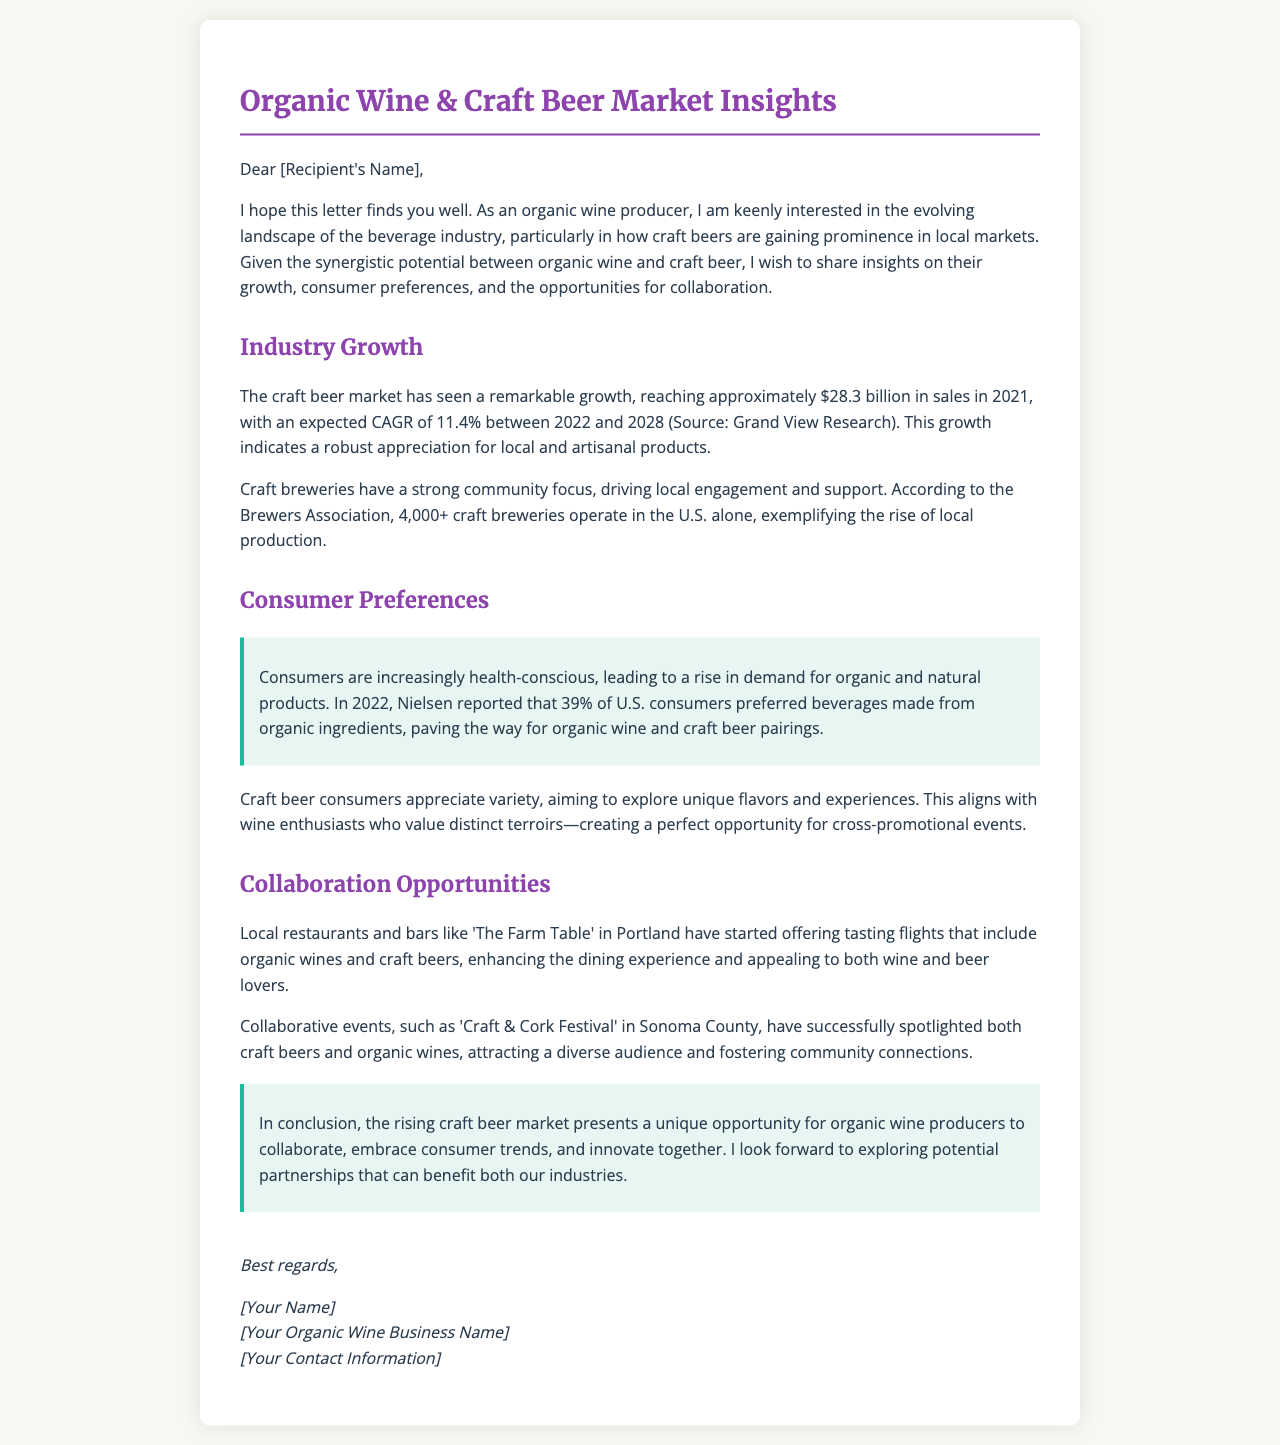what is the craft beer market's sales figure in 2021? The document states that the craft beer market reached approximately $28.3 billion in sales in 2021.
Answer: $28.3 billion what is the expected CAGR for the craft beer market from 2022 to 2028? The document mentions that the expected CAGR is 11.4% between 2022 and 2028.
Answer: 11.4% how many craft breweries operate in the U.S.? According to the Brewers Association, there are over 4,000 craft breweries operating in the U.S.
Answer: 4,000+ what percentage of U.S. consumers preferred beverages made from organic ingredients in 2022? The document reports that 39% of U.S. consumers preferred beverages made from organic ingredients in 2022.
Answer: 39% what collaborative event is mentioned as successful in spotlighting craft beers and organic wines? The document refers to the 'Craft & Cork Festival' in Sonoma County as a successful event.
Answer: Craft & Cork Festival what type of establishments are starting to offer tasting flights including organic wines and craft beers? The document mentions that local restaurants and bars like 'The Farm Table' in Portland have started offering such tasting flights.
Answer: Restaurants and bars what is the main focus of craft breweries according to the document? The document states that craft breweries have a strong community focus, driving local engagement and support.
Answer: Community focus what is the concluding remark in the letter regarding opportunities for organic wine producers? The letter concludes that the rising craft beer market presents a unique opportunity for organic wine producers to collaborate.
Answer: Unique opportunity for collaboration 